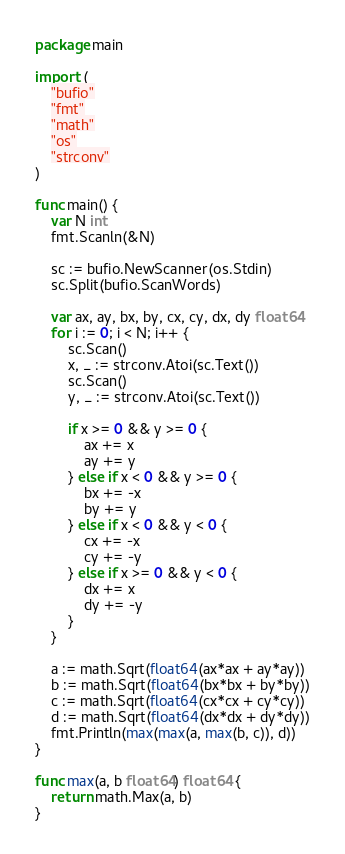Convert code to text. <code><loc_0><loc_0><loc_500><loc_500><_Go_>package main

import (
	"bufio"
	"fmt"
	"math"
	"os"
	"strconv"
)

func main() {
	var N int
	fmt.Scanln(&N)

	sc := bufio.NewScanner(os.Stdin)
	sc.Split(bufio.ScanWords)

	var ax, ay, bx, by, cx, cy, dx, dy float64
	for i := 0; i < N; i++ {
		sc.Scan()
		x, _ := strconv.Atoi(sc.Text())
		sc.Scan()
		y, _ := strconv.Atoi(sc.Text())

		if x >= 0 && y >= 0 {
			ax += x
			ay += y
		} else if x < 0 && y >= 0 {
			bx += -x
			by += y
		} else if x < 0 && y < 0 {
			cx += -x
			cy += -y
		} else if x >= 0 && y < 0 {
			dx += x
			dy += -y
		}
	}

	a := math.Sqrt(float64(ax*ax + ay*ay))
	b := math.Sqrt(float64(bx*bx + by*by))
	c := math.Sqrt(float64(cx*cx + cy*cy))
	d := math.Sqrt(float64(dx*dx + dy*dy))
	fmt.Println(max(max(a, max(b, c)), d))
}

func max(a, b float64) float64 {
	return math.Max(a, b)
}
</code> 